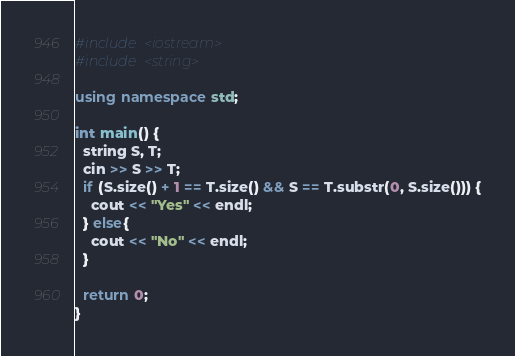<code> <loc_0><loc_0><loc_500><loc_500><_C++_>#include <iostream>
#include <string>

using namespace std;

int main() {
  string S, T;
  cin >> S >> T;
  if (S.size() + 1 == T.size() && S == T.substr(0, S.size())) {
    cout << "Yes" << endl;
  } else{
    cout << "No" << endl;
  } 
  
  return 0;
}
</code> 